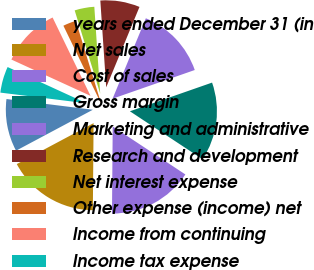<chart> <loc_0><loc_0><loc_500><loc_500><pie_chart><fcel>years ended December 31 (in<fcel>Net sales<fcel>Cost of sales<fcel>Gross margin<fcel>Marketing and administrative<fcel>Research and development<fcel>Net interest expense<fcel>Other expense (income) net<fcel>Income from continuing<fcel>Income tax expense<nl><fcel>9.76%<fcel>17.07%<fcel>15.85%<fcel>14.63%<fcel>13.41%<fcel>7.32%<fcel>3.66%<fcel>2.44%<fcel>10.98%<fcel>4.88%<nl></chart> 